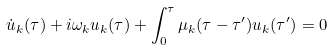<formula> <loc_0><loc_0><loc_500><loc_500>\dot { u } _ { k } ( \tau ) + i \omega _ { k } u _ { k } ( \tau ) + \int ^ { \tau } _ { 0 } \mu _ { k } ( \tau - \tau ^ { \prime } ) u _ { k } ( \tau ^ { \prime } ) = 0</formula> 